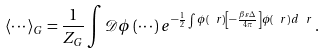<formula> <loc_0><loc_0><loc_500><loc_500>\langle \cdots \rangle _ { G } = \frac { 1 } { Z _ { G } } \int \mathcal { D } \phi \, ( \cdots ) \, e ^ { - \frac { 1 } { 2 } \int \phi ( \ r ) \left [ - \frac { \beta \varepsilon \Delta } { 4 \pi } \right ] \phi ( \ r ) \, d \ r } \, .</formula> 